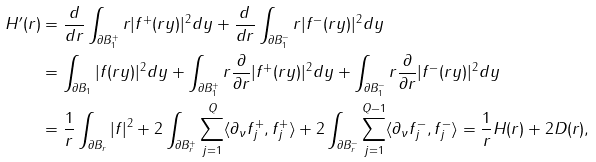<formula> <loc_0><loc_0><loc_500><loc_500>H ^ { \prime } ( r ) & = \frac { d } { d r } \int _ { \partial B _ { 1 } ^ { + } } r | f ^ { + } ( r y ) | ^ { 2 } d y + \frac { d } { d r } \int _ { \partial B _ { 1 } ^ { - } } r | f ^ { - } ( r y ) | ^ { 2 } d y \\ & = \int _ { \partial B _ { 1 } } | f ( r y ) | ^ { 2 } d y + \int _ { \partial B _ { 1 } ^ { + } } r \frac { \partial } { \partial r } | f ^ { + } ( r y ) | ^ { 2 } d y + \int _ { \partial B _ { 1 } ^ { - } } r \frac { \partial } { \partial r } | f ^ { - } ( r y ) | ^ { 2 } d y \\ & = \frac { 1 } { r } \int _ { \partial B _ { r } } | f | ^ { 2 } + 2 \int _ { \partial B _ { r } ^ { + } } \sum _ { j = 1 } ^ { Q } \langle \partial _ { \nu } f _ { j } ^ { + } , f _ { j } ^ { + } \rangle + 2 \int _ { \partial B _ { r } ^ { - } } \sum _ { j = 1 } ^ { Q - 1 } \langle \partial _ { \nu } f _ { j } ^ { - } , f _ { j } ^ { - } \rangle = \frac { 1 } { r } H ( r ) + 2 D ( r ) ,</formula> 